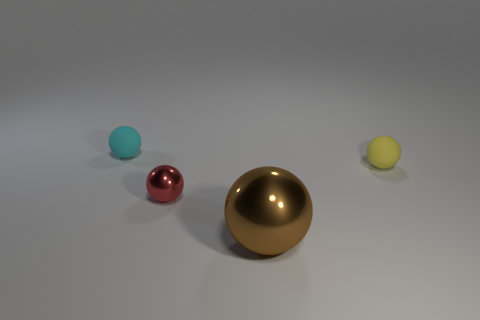What shape is the small object that is behind the matte ball that is right of the large metallic ball? The small object positioned behind the matte ball, which in turn is to the right of the large metallic ball, appears to be a sphere; however, without a full 360-degree view, we cannot conclusively determine its shape from this single vantage point. 